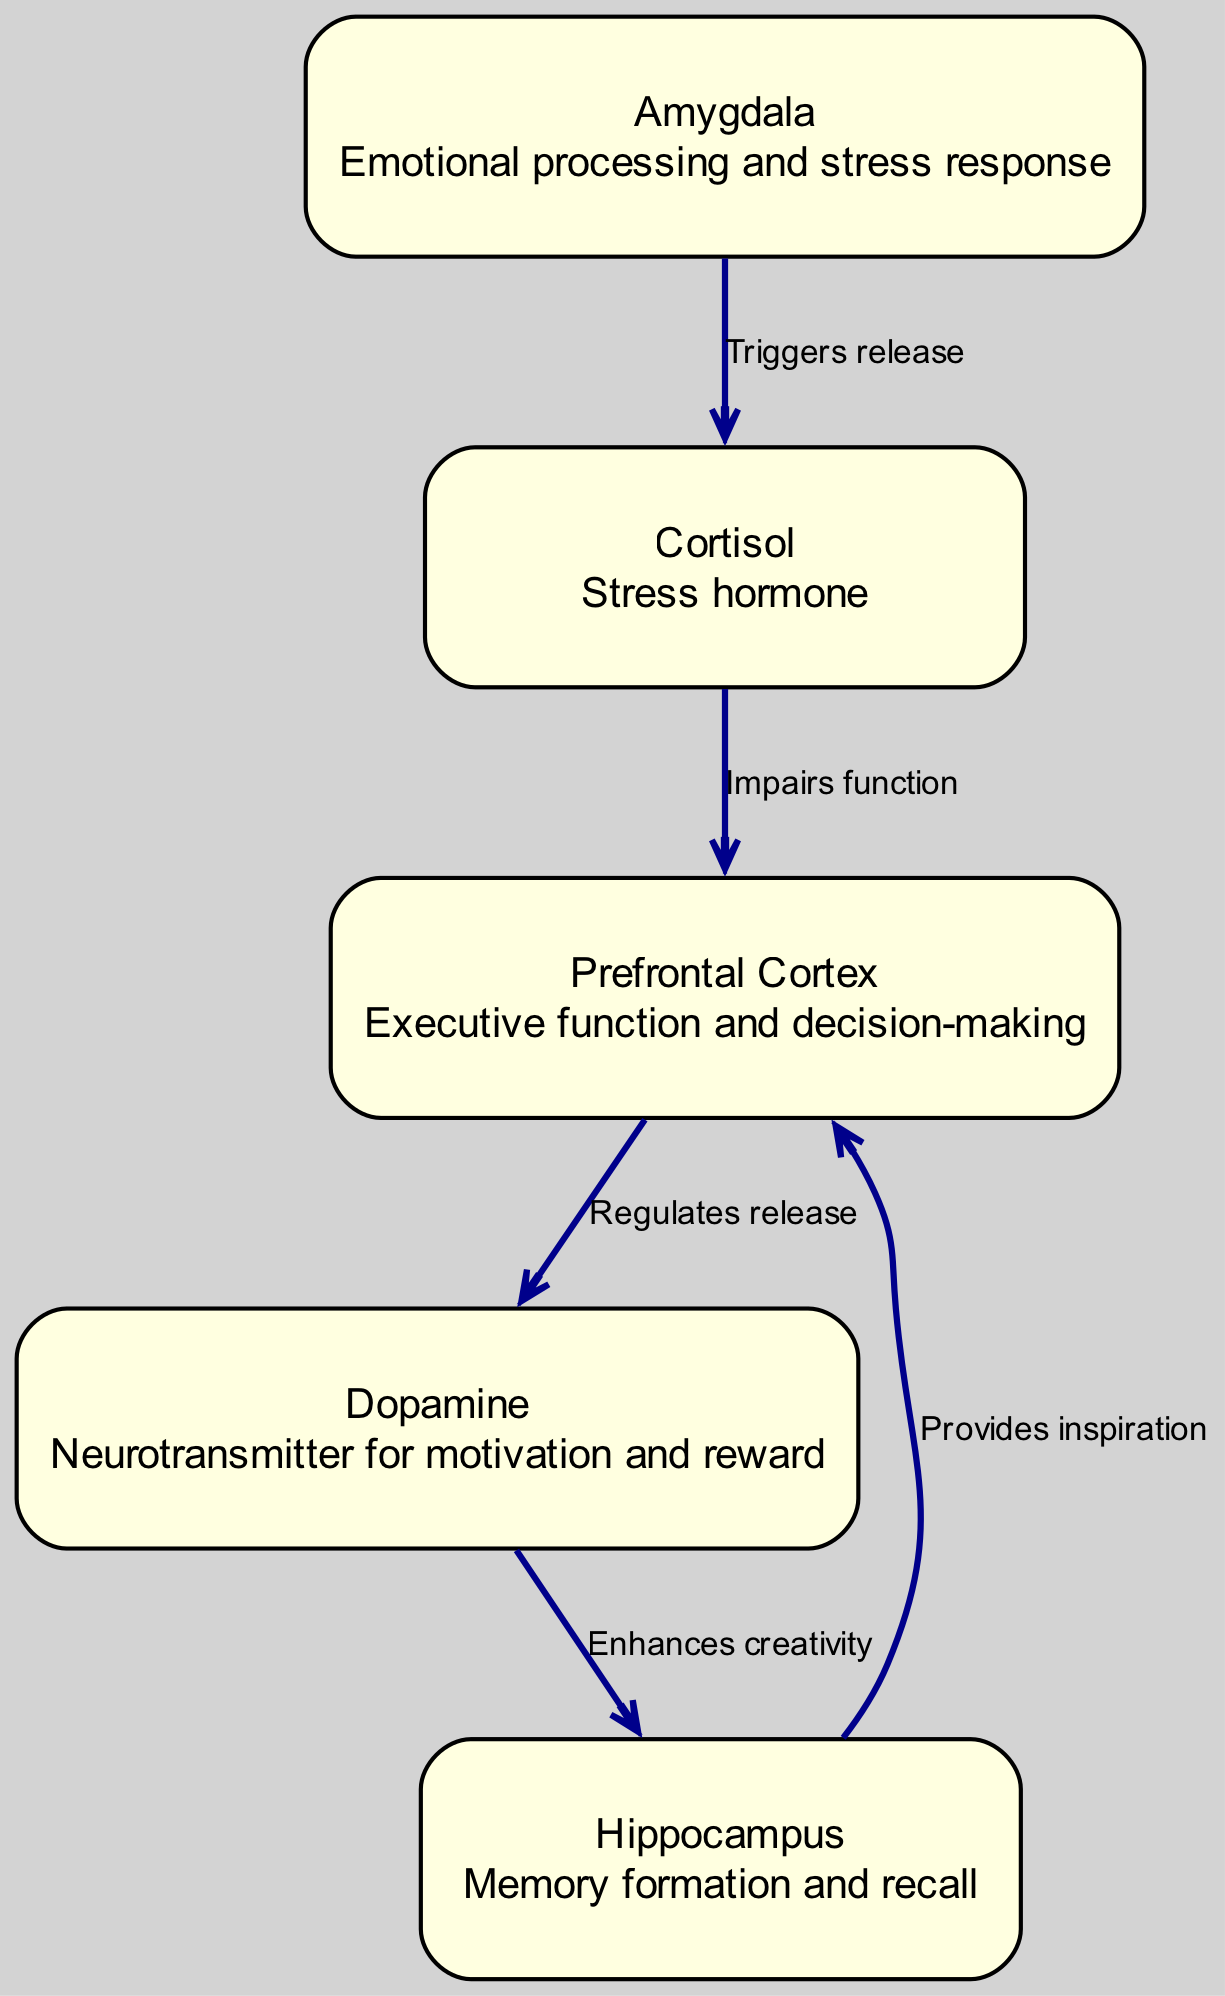What is the function of the Prefrontal Cortex? The diagram states that the Prefrontal Cortex is responsible for "Executive function and decision-making." Therefore, I read the description for the Prefrontal Cortex node to find this information.
Answer: Executive function and decision-making How many nodes are present in the diagram? The diagram lists five nodes: Prefrontal Cortex, Amygdala, Hippocampus, Dopamine, and Cortisol. By counting each node, I confirm there are five.
Answer: 5 Which hormone is associated with stress in the diagram? The diagram identifies Cortisol as the "Stress hormone." I locate the node for Cortisol and check its description for confirmation.
Answer: Cortisol What does the Amygdala trigger the release of? According to the edges, the diagram shows that the Amygdala triggers the release of Cortisol. I follow the edge from the Amygdala node to the Cortisol node and verify this relationship.
Answer: Cortisol How does the Prefrontal Cortex interact with Dopamine? The diagram specifies that the Prefrontal Cortex "Regulates release" of Dopamine. To answer this, I look at the edge from the Prefrontal Cortex to the Dopamine node and read its label.
Answer: Regulates release What is the relationship between Dopamine and the Hippocampus? The diagram indicates that Dopamine "Enhances creativity" and has an edge directing towards the Hippocampus. To answer this, I trace the edge from the Dopamine node to the Hippocampus node and check the label.
Answer: Enhances creativity Explain how stress affects the Prefrontal Cortex. The diagram shows that Cortisol, which is released as a stress response from the Amygdala, "Impairs function" in the Prefrontal Cortex. Following the flow: Amygdala triggers release of Cortisol, and then Cortisol impairs function in the Prefrontal Cortex, clearly outlines this part of the mechanism.
Answer: Impairs function What provides inspiration for the Prefrontal Cortex? I refer to the diagram where it states that the Hippocampus "Provides inspiration" for the Prefrontal Cortex. I identify the edge leading from the Hippocampus to the Prefrontal Cortex and read its label.
Answer: Provides inspiration Which area enhances creativity and is influenced by Dopamine? The diagram reveals that the Hippocampus, influenced by Dopamine, is responsible for enhancing creativity. I check the flow: Dopamine enhances creativity towards the Hippocampus.
Answer: Hippocampus 